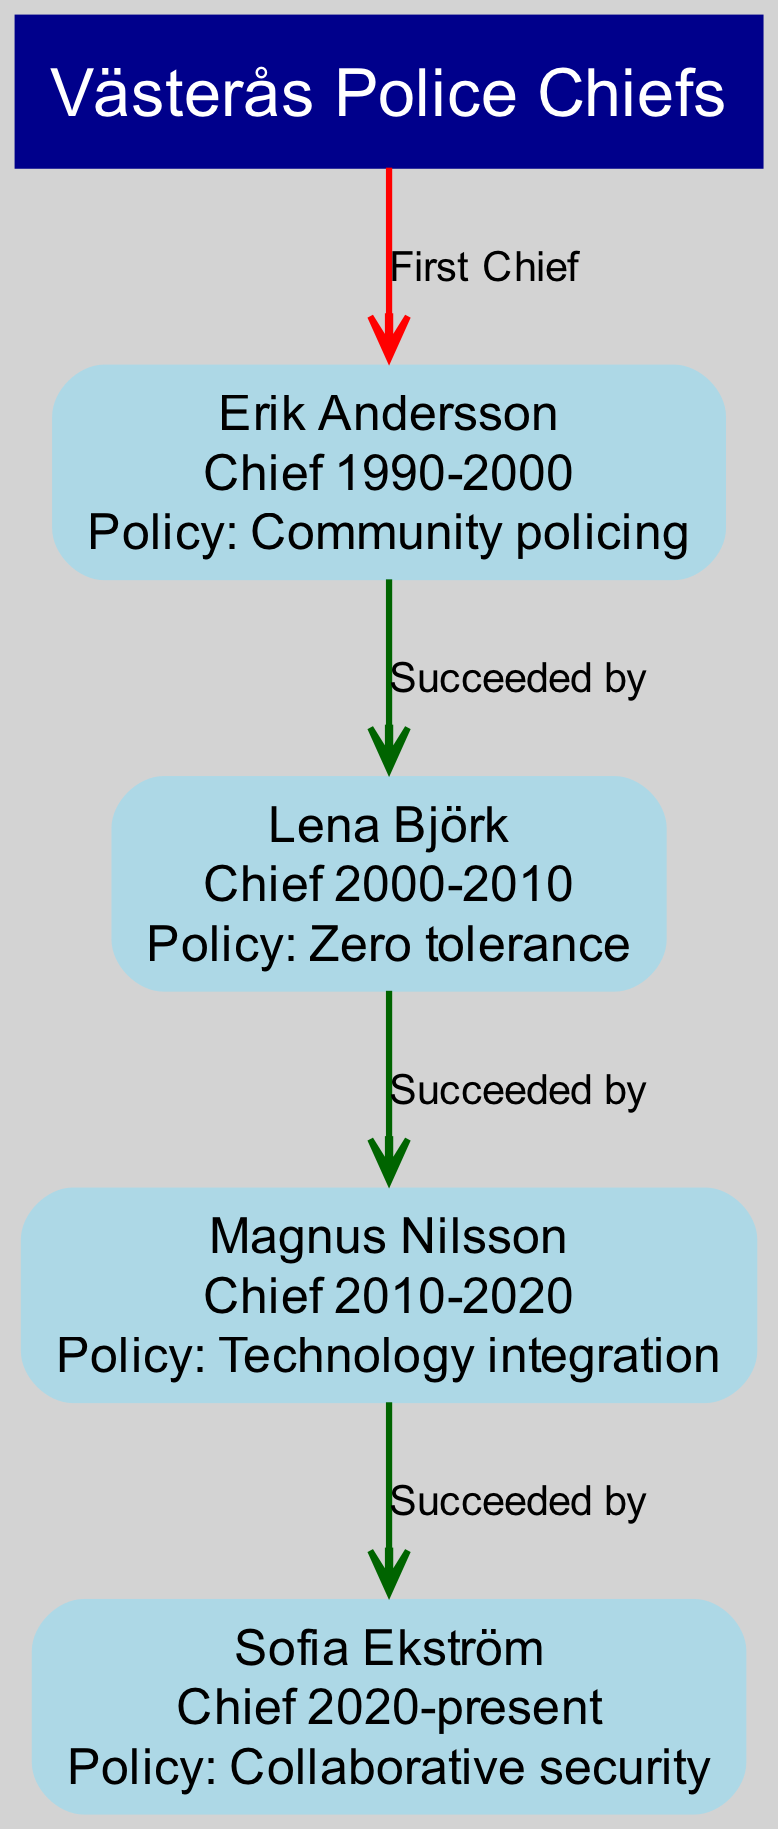What is the name of the current police chief? The current police chief is the last node in the diagram, which is "Sofia Ekström" since she holds the position from 2020 to the present.
Answer: Sofia Ekström Who succeeded Erik Andersson? The relationship "Succeeded by" clearly indicates that Lena Björk follows Erik Andersson directly in the diagram.
Answer: Lena Björk What was the policy during Magnus Nilsson's term? The policy associated with Magnus Nilsson, who served from 2010 to 2020, is listed as "Technology integration" within the node.
Answer: Technology integration How many police chiefs have there been since 1990? There are four nodes representing police chiefs in the diagram, indicating the number of police chiefs since 1990, starting with Erik Andersson through to Sofia Ekström.
Answer: 4 What policy did Lena Björk implement? Lena Björk's policy is noted in her node as "Zero tolerance," which was the focus during her time as police chief from 2000 to 2010.
Answer: Zero tolerance Who is the first police chief in the diagram? The first police chief is represented by the first node, which is Erik Andersson, who served from 1990 to 2000.
Answer: Erik Andersson What type of relationship exists between Magnus Nilsson and Sofia Ekström? The relationship defined in the diagram is "Succeeded by," indicating that Magnus Nilsson preceded Sofia Ekström as police chief.
Answer: Succeeded by Which chief's term focused on community policing? The term representing community policing is attributed to Erik Andersson, who was the chief from 1990 to 2000, as indicated in his node.
Answer: Erik Andersson What is the total number of relationships shown in the diagram? The relationships shown in the diagram include three connections, one for each succession between the police chiefs.
Answer: 3 